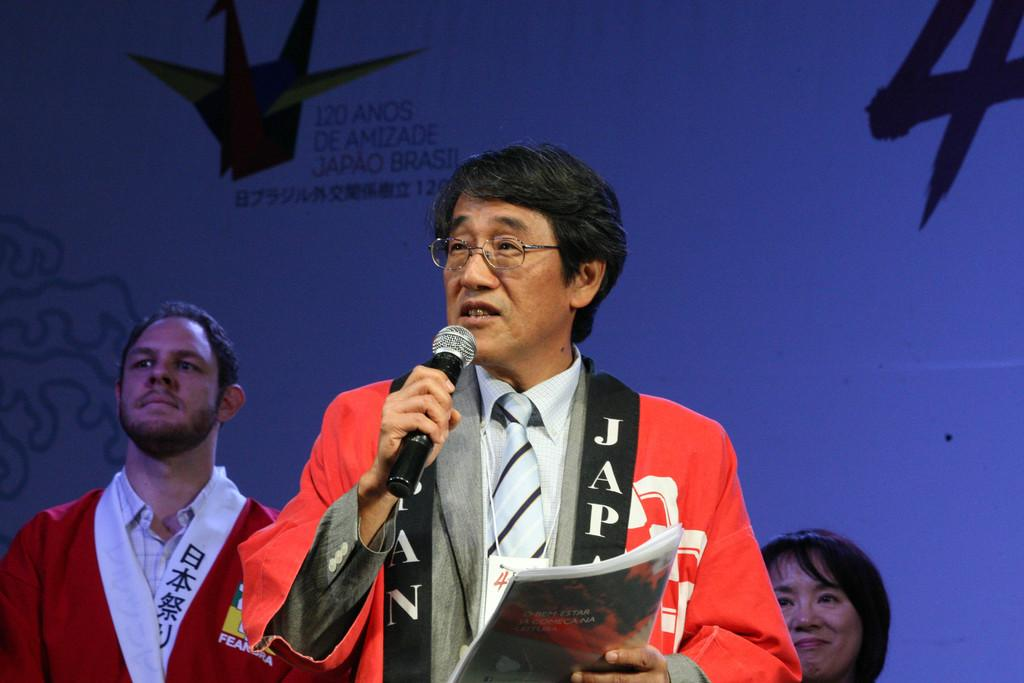Provide a one-sentence caption for the provided image. A man talking at 120 Anos De Amizade. 